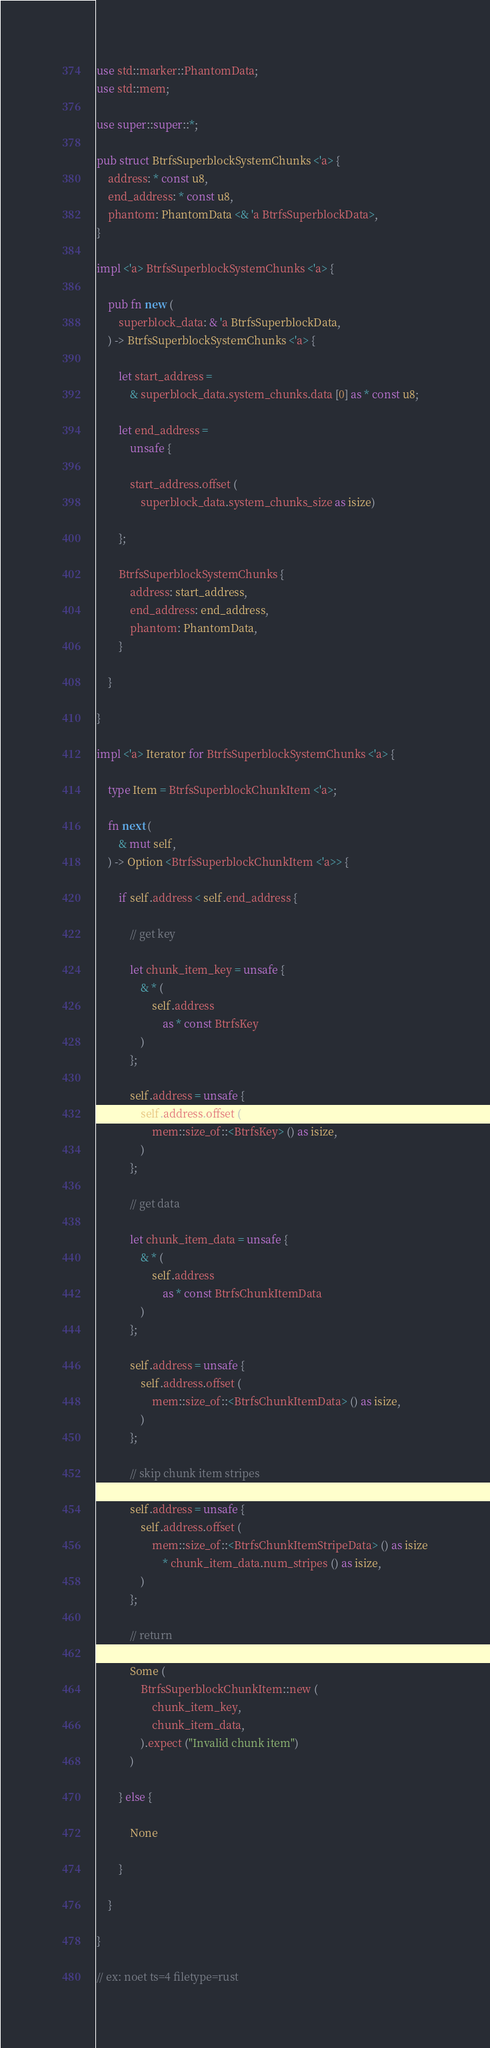<code> <loc_0><loc_0><loc_500><loc_500><_Rust_>use std::marker::PhantomData;
use std::mem;

use super::super::*;

pub struct BtrfsSuperblockSystemChunks <'a> {
	address: * const u8,
	end_address: * const u8,
	phantom: PhantomData <& 'a BtrfsSuperblockData>,
}

impl <'a> BtrfsSuperblockSystemChunks <'a> {

	pub fn new (
		superblock_data: & 'a BtrfsSuperblockData,
	) -> BtrfsSuperblockSystemChunks <'a> {

		let start_address =
			& superblock_data.system_chunks.data [0] as * const u8;

		let end_address =
			unsafe {

			start_address.offset (
				superblock_data.system_chunks_size as isize)

		};

		BtrfsSuperblockSystemChunks {
			address: start_address,
			end_address: end_address,
			phantom: PhantomData,
		}

	}

}

impl <'a> Iterator for BtrfsSuperblockSystemChunks <'a> {

	type Item = BtrfsSuperblockChunkItem <'a>;

	fn next (
		& mut self,
	) -> Option <BtrfsSuperblockChunkItem <'a>> {

		if self.address < self.end_address {

			// get key

			let chunk_item_key = unsafe {
				& * (
					self.address
						as * const BtrfsKey
				)
			};

			self.address = unsafe {
				self.address.offset (
					mem::size_of::<BtrfsKey> () as isize,
				)
			};

			// get data

			let chunk_item_data = unsafe {
				& * (
					self.address
						as * const BtrfsChunkItemData
				)
			};

			self.address = unsafe {
				self.address.offset (
					mem::size_of::<BtrfsChunkItemData> () as isize,
				)
			};

			// skip chunk item stripes

			self.address = unsafe {
				self.address.offset (
					mem::size_of::<BtrfsChunkItemStripeData> () as isize
						* chunk_item_data.num_stripes () as isize,
				)
			};

			// return

			Some (
				BtrfsSuperblockChunkItem::new (
					chunk_item_key,
					chunk_item_data,
				).expect ("Invalid chunk item")
			)

		} else {

			None

		}

	}

}

// ex: noet ts=4 filetype=rust
</code> 